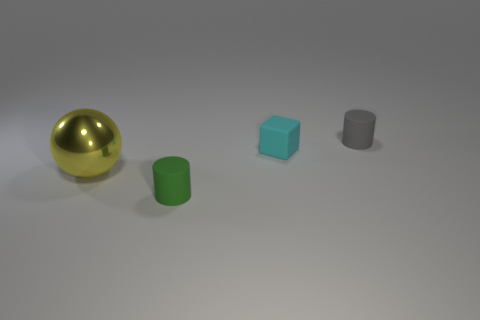How many other things are there of the same shape as the gray thing?
Your answer should be compact. 1. What number of other small matte cubes have the same color as the block?
Offer a terse response. 0. There is another small cylinder that is the same material as the small green cylinder; what color is it?
Your answer should be compact. Gray. Are there any rubber things of the same size as the yellow sphere?
Offer a terse response. No. Is the number of yellow shiny things behind the gray rubber object greater than the number of small green cylinders to the right of the green matte cylinder?
Your answer should be compact. No. Do the tiny thing in front of the metallic sphere and the small cylinder that is right of the cyan cube have the same material?
Provide a short and direct response. Yes. What shape is the green matte thing that is the same size as the gray rubber object?
Provide a succinct answer. Cylinder. Is there a small blue object that has the same shape as the large yellow shiny thing?
Your answer should be compact. No. There is a cylinder behind the large sphere; is its color the same as the small matte cylinder that is on the left side of the tiny gray cylinder?
Make the answer very short. No. Are there any tiny cylinders on the right side of the small gray object?
Offer a terse response. No. 